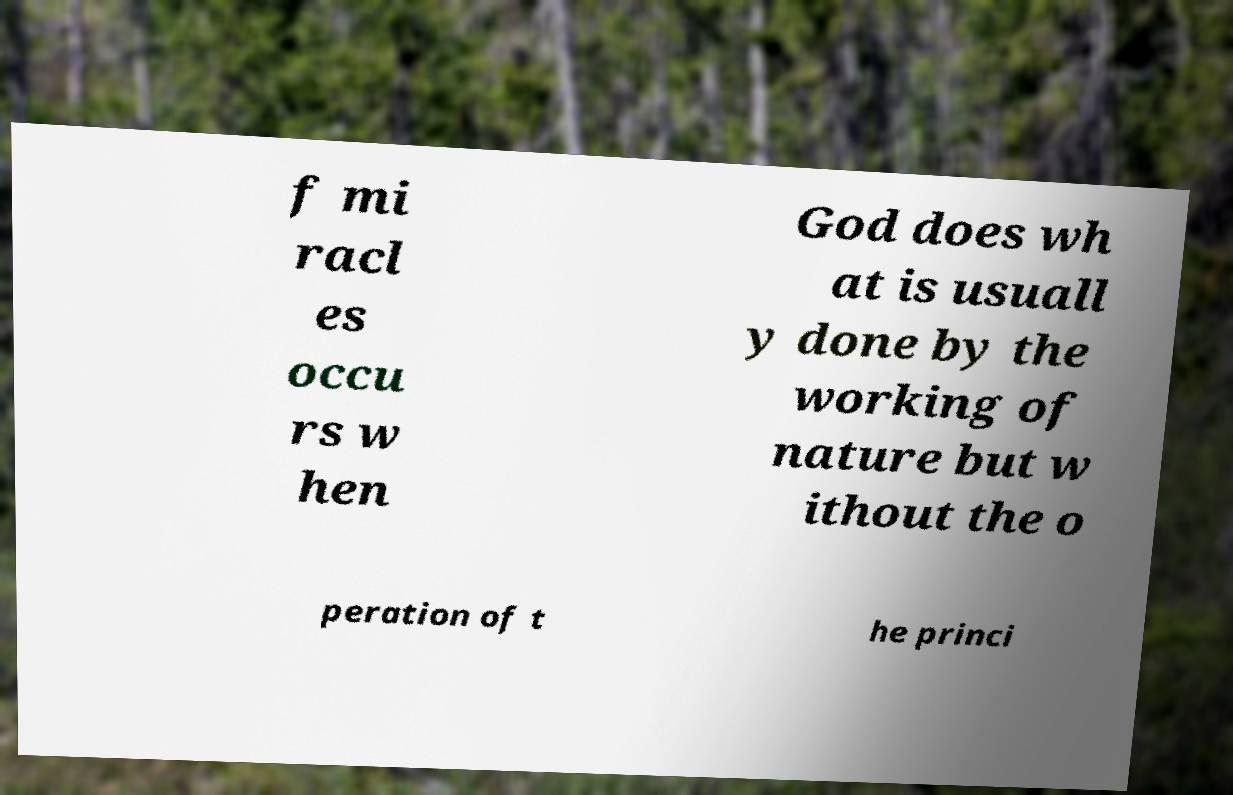Please read and relay the text visible in this image. What does it say? f mi racl es occu rs w hen God does wh at is usuall y done by the working of nature but w ithout the o peration of t he princi 